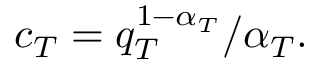Convert formula to latex. <formula><loc_0><loc_0><loc_500><loc_500>c _ { T } = q _ { T } ^ { 1 - \alpha _ { T } } / \alpha _ { T } .</formula> 